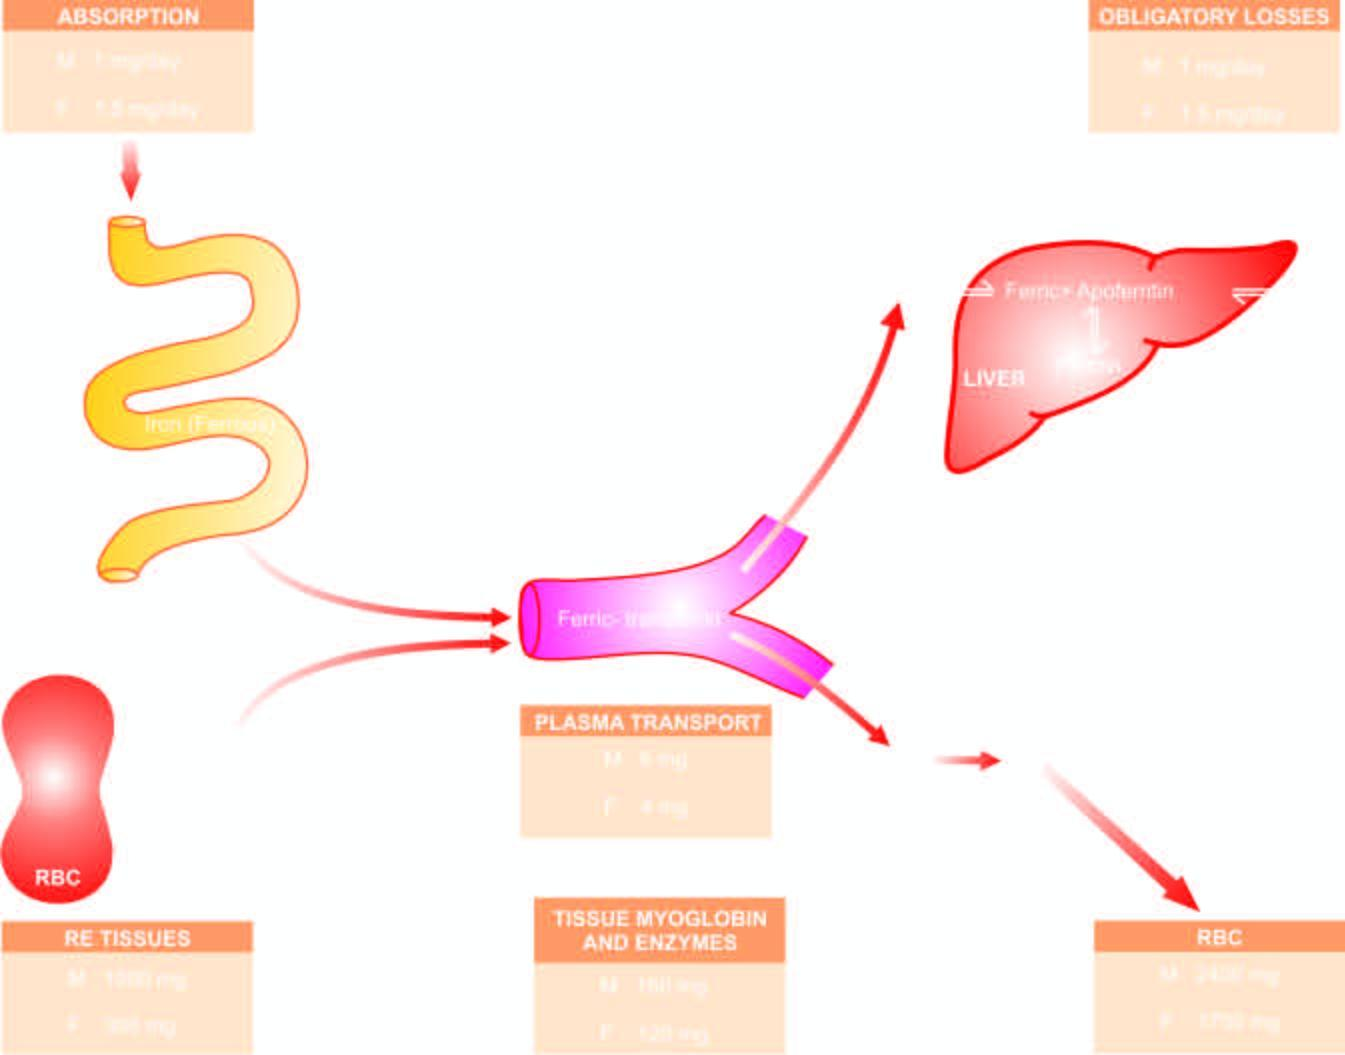what is iron stored as?
Answer the question using a single word or phrase. Ferritin and haemosiderin 